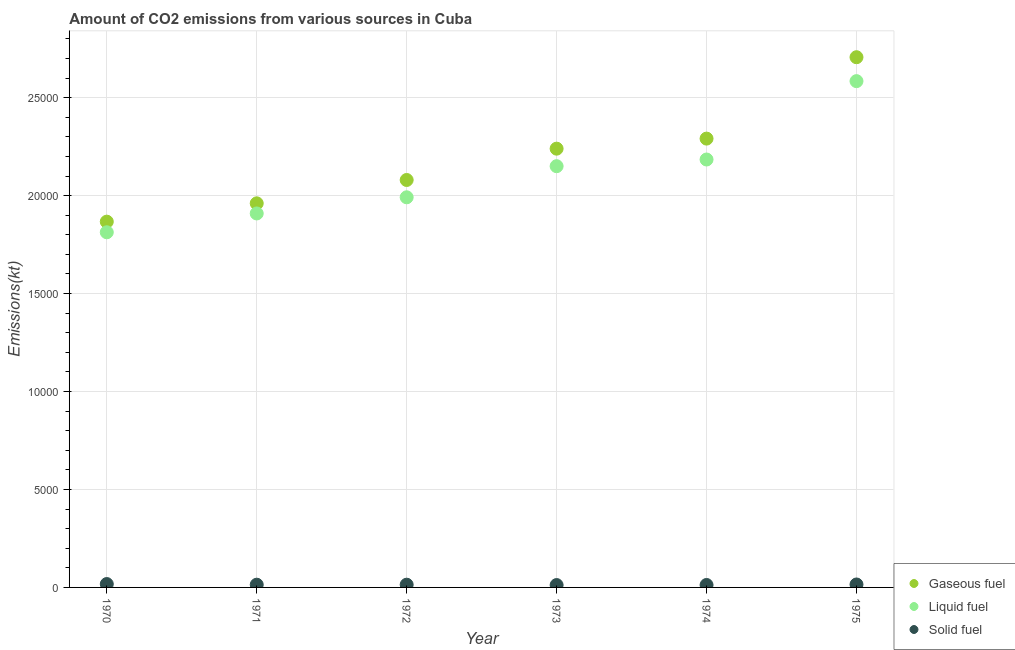How many different coloured dotlines are there?
Keep it short and to the point. 3. Is the number of dotlines equal to the number of legend labels?
Your answer should be very brief. Yes. What is the amount of co2 emissions from gaseous fuel in 1975?
Provide a succinct answer. 2.71e+04. Across all years, what is the maximum amount of co2 emissions from liquid fuel?
Ensure brevity in your answer.  2.58e+04. Across all years, what is the minimum amount of co2 emissions from gaseous fuel?
Ensure brevity in your answer.  1.87e+04. In which year was the amount of co2 emissions from solid fuel maximum?
Ensure brevity in your answer.  1970. In which year was the amount of co2 emissions from liquid fuel minimum?
Keep it short and to the point. 1970. What is the total amount of co2 emissions from liquid fuel in the graph?
Offer a very short reply. 1.26e+05. What is the difference between the amount of co2 emissions from liquid fuel in 1973 and that in 1975?
Keep it short and to the point. -4341.73. What is the difference between the amount of co2 emissions from solid fuel in 1973 and the amount of co2 emissions from liquid fuel in 1971?
Offer a very short reply. -1.90e+04. What is the average amount of co2 emissions from gaseous fuel per year?
Keep it short and to the point. 2.19e+04. In the year 1972, what is the difference between the amount of co2 emissions from gaseous fuel and amount of co2 emissions from liquid fuel?
Give a very brief answer. 883.75. What is the ratio of the amount of co2 emissions from liquid fuel in 1972 to that in 1974?
Provide a succinct answer. 0.91. Is the amount of co2 emissions from gaseous fuel in 1970 less than that in 1972?
Offer a very short reply. Yes. What is the difference between the highest and the second highest amount of co2 emissions from solid fuel?
Your response must be concise. 22. What is the difference between the highest and the lowest amount of co2 emissions from gaseous fuel?
Keep it short and to the point. 8393.76. Is it the case that in every year, the sum of the amount of co2 emissions from gaseous fuel and amount of co2 emissions from liquid fuel is greater than the amount of co2 emissions from solid fuel?
Offer a very short reply. Yes. Is the amount of co2 emissions from solid fuel strictly greater than the amount of co2 emissions from gaseous fuel over the years?
Your answer should be very brief. No. Does the graph contain any zero values?
Provide a succinct answer. No. Where does the legend appear in the graph?
Provide a short and direct response. Bottom right. How many legend labels are there?
Provide a succinct answer. 3. What is the title of the graph?
Provide a short and direct response. Amount of CO2 emissions from various sources in Cuba. Does "ICT services" appear as one of the legend labels in the graph?
Your answer should be very brief. No. What is the label or title of the Y-axis?
Your answer should be very brief. Emissions(kt). What is the Emissions(kt) in Gaseous fuel in 1970?
Your response must be concise. 1.87e+04. What is the Emissions(kt) in Liquid fuel in 1970?
Your response must be concise. 1.81e+04. What is the Emissions(kt) in Solid fuel in 1970?
Your response must be concise. 172.35. What is the Emissions(kt) in Gaseous fuel in 1971?
Your answer should be very brief. 1.96e+04. What is the Emissions(kt) in Liquid fuel in 1971?
Offer a terse response. 1.91e+04. What is the Emissions(kt) in Solid fuel in 1971?
Keep it short and to the point. 139.35. What is the Emissions(kt) of Gaseous fuel in 1972?
Your answer should be very brief. 2.08e+04. What is the Emissions(kt) of Liquid fuel in 1972?
Ensure brevity in your answer.  1.99e+04. What is the Emissions(kt) of Solid fuel in 1972?
Provide a short and direct response. 139.35. What is the Emissions(kt) in Gaseous fuel in 1973?
Offer a very short reply. 2.24e+04. What is the Emissions(kt) of Liquid fuel in 1973?
Ensure brevity in your answer.  2.15e+04. What is the Emissions(kt) in Solid fuel in 1973?
Give a very brief answer. 121.01. What is the Emissions(kt) in Gaseous fuel in 1974?
Your answer should be very brief. 2.29e+04. What is the Emissions(kt) of Liquid fuel in 1974?
Your answer should be compact. 2.18e+04. What is the Emissions(kt) of Solid fuel in 1974?
Ensure brevity in your answer.  124.68. What is the Emissions(kt) of Gaseous fuel in 1975?
Offer a terse response. 2.71e+04. What is the Emissions(kt) in Liquid fuel in 1975?
Ensure brevity in your answer.  2.58e+04. What is the Emissions(kt) of Solid fuel in 1975?
Provide a succinct answer. 150.35. Across all years, what is the maximum Emissions(kt) of Gaseous fuel?
Give a very brief answer. 2.71e+04. Across all years, what is the maximum Emissions(kt) in Liquid fuel?
Ensure brevity in your answer.  2.58e+04. Across all years, what is the maximum Emissions(kt) in Solid fuel?
Keep it short and to the point. 172.35. Across all years, what is the minimum Emissions(kt) in Gaseous fuel?
Provide a short and direct response. 1.87e+04. Across all years, what is the minimum Emissions(kt) of Liquid fuel?
Make the answer very short. 1.81e+04. Across all years, what is the minimum Emissions(kt) of Solid fuel?
Your response must be concise. 121.01. What is the total Emissions(kt) of Gaseous fuel in the graph?
Your answer should be compact. 1.31e+05. What is the total Emissions(kt) in Liquid fuel in the graph?
Provide a succinct answer. 1.26e+05. What is the total Emissions(kt) in Solid fuel in the graph?
Make the answer very short. 847.08. What is the difference between the Emissions(kt) in Gaseous fuel in 1970 and that in 1971?
Your response must be concise. -935.09. What is the difference between the Emissions(kt) of Liquid fuel in 1970 and that in 1971?
Make the answer very short. -960.75. What is the difference between the Emissions(kt) of Solid fuel in 1970 and that in 1971?
Provide a succinct answer. 33. What is the difference between the Emissions(kt) in Gaseous fuel in 1970 and that in 1972?
Make the answer very short. -2126.86. What is the difference between the Emissions(kt) in Liquid fuel in 1970 and that in 1972?
Offer a terse response. -1785.83. What is the difference between the Emissions(kt) in Solid fuel in 1970 and that in 1972?
Ensure brevity in your answer.  33. What is the difference between the Emissions(kt) in Gaseous fuel in 1970 and that in 1973?
Ensure brevity in your answer.  -3725.67. What is the difference between the Emissions(kt) in Liquid fuel in 1970 and that in 1973?
Keep it short and to the point. -3373.64. What is the difference between the Emissions(kt) of Solid fuel in 1970 and that in 1973?
Give a very brief answer. 51.34. What is the difference between the Emissions(kt) of Gaseous fuel in 1970 and that in 1974?
Ensure brevity in your answer.  -4239.05. What is the difference between the Emissions(kt) in Liquid fuel in 1970 and that in 1974?
Make the answer very short. -3714.67. What is the difference between the Emissions(kt) of Solid fuel in 1970 and that in 1974?
Your answer should be very brief. 47.67. What is the difference between the Emissions(kt) in Gaseous fuel in 1970 and that in 1975?
Your answer should be very brief. -8393.76. What is the difference between the Emissions(kt) of Liquid fuel in 1970 and that in 1975?
Your answer should be very brief. -7715.37. What is the difference between the Emissions(kt) in Solid fuel in 1970 and that in 1975?
Provide a succinct answer. 22. What is the difference between the Emissions(kt) of Gaseous fuel in 1971 and that in 1972?
Your response must be concise. -1191.78. What is the difference between the Emissions(kt) in Liquid fuel in 1971 and that in 1972?
Provide a succinct answer. -825.08. What is the difference between the Emissions(kt) of Gaseous fuel in 1971 and that in 1973?
Provide a short and direct response. -2790.59. What is the difference between the Emissions(kt) in Liquid fuel in 1971 and that in 1973?
Provide a short and direct response. -2412.89. What is the difference between the Emissions(kt) in Solid fuel in 1971 and that in 1973?
Offer a terse response. 18.34. What is the difference between the Emissions(kt) in Gaseous fuel in 1971 and that in 1974?
Your response must be concise. -3303.97. What is the difference between the Emissions(kt) in Liquid fuel in 1971 and that in 1974?
Offer a terse response. -2753.92. What is the difference between the Emissions(kt) in Solid fuel in 1971 and that in 1974?
Keep it short and to the point. 14.67. What is the difference between the Emissions(kt) of Gaseous fuel in 1971 and that in 1975?
Your answer should be compact. -7458.68. What is the difference between the Emissions(kt) of Liquid fuel in 1971 and that in 1975?
Offer a terse response. -6754.61. What is the difference between the Emissions(kt) in Solid fuel in 1971 and that in 1975?
Provide a short and direct response. -11. What is the difference between the Emissions(kt) in Gaseous fuel in 1972 and that in 1973?
Give a very brief answer. -1598.81. What is the difference between the Emissions(kt) in Liquid fuel in 1972 and that in 1973?
Provide a short and direct response. -1587.81. What is the difference between the Emissions(kt) of Solid fuel in 1972 and that in 1973?
Offer a terse response. 18.34. What is the difference between the Emissions(kt) in Gaseous fuel in 1972 and that in 1974?
Keep it short and to the point. -2112.19. What is the difference between the Emissions(kt) in Liquid fuel in 1972 and that in 1974?
Offer a very short reply. -1928.84. What is the difference between the Emissions(kt) in Solid fuel in 1972 and that in 1974?
Provide a succinct answer. 14.67. What is the difference between the Emissions(kt) in Gaseous fuel in 1972 and that in 1975?
Keep it short and to the point. -6266.9. What is the difference between the Emissions(kt) of Liquid fuel in 1972 and that in 1975?
Provide a succinct answer. -5929.54. What is the difference between the Emissions(kt) of Solid fuel in 1972 and that in 1975?
Keep it short and to the point. -11. What is the difference between the Emissions(kt) in Gaseous fuel in 1973 and that in 1974?
Your answer should be compact. -513.38. What is the difference between the Emissions(kt) of Liquid fuel in 1973 and that in 1974?
Offer a terse response. -341.03. What is the difference between the Emissions(kt) of Solid fuel in 1973 and that in 1974?
Your response must be concise. -3.67. What is the difference between the Emissions(kt) in Gaseous fuel in 1973 and that in 1975?
Offer a terse response. -4668.09. What is the difference between the Emissions(kt) of Liquid fuel in 1973 and that in 1975?
Provide a short and direct response. -4341.73. What is the difference between the Emissions(kt) in Solid fuel in 1973 and that in 1975?
Keep it short and to the point. -29.34. What is the difference between the Emissions(kt) of Gaseous fuel in 1974 and that in 1975?
Give a very brief answer. -4154.71. What is the difference between the Emissions(kt) in Liquid fuel in 1974 and that in 1975?
Your response must be concise. -4000.7. What is the difference between the Emissions(kt) in Solid fuel in 1974 and that in 1975?
Make the answer very short. -25.67. What is the difference between the Emissions(kt) in Gaseous fuel in 1970 and the Emissions(kt) in Liquid fuel in 1971?
Give a very brief answer. -418.04. What is the difference between the Emissions(kt) in Gaseous fuel in 1970 and the Emissions(kt) in Solid fuel in 1971?
Offer a very short reply. 1.85e+04. What is the difference between the Emissions(kt) in Liquid fuel in 1970 and the Emissions(kt) in Solid fuel in 1971?
Your response must be concise. 1.80e+04. What is the difference between the Emissions(kt) of Gaseous fuel in 1970 and the Emissions(kt) of Liquid fuel in 1972?
Your answer should be very brief. -1243.11. What is the difference between the Emissions(kt) in Gaseous fuel in 1970 and the Emissions(kt) in Solid fuel in 1972?
Offer a terse response. 1.85e+04. What is the difference between the Emissions(kt) in Liquid fuel in 1970 and the Emissions(kt) in Solid fuel in 1972?
Provide a short and direct response. 1.80e+04. What is the difference between the Emissions(kt) in Gaseous fuel in 1970 and the Emissions(kt) in Liquid fuel in 1973?
Ensure brevity in your answer.  -2830.92. What is the difference between the Emissions(kt) in Gaseous fuel in 1970 and the Emissions(kt) in Solid fuel in 1973?
Give a very brief answer. 1.86e+04. What is the difference between the Emissions(kt) in Liquid fuel in 1970 and the Emissions(kt) in Solid fuel in 1973?
Provide a short and direct response. 1.80e+04. What is the difference between the Emissions(kt) in Gaseous fuel in 1970 and the Emissions(kt) in Liquid fuel in 1974?
Ensure brevity in your answer.  -3171.95. What is the difference between the Emissions(kt) of Gaseous fuel in 1970 and the Emissions(kt) of Solid fuel in 1974?
Your response must be concise. 1.85e+04. What is the difference between the Emissions(kt) in Liquid fuel in 1970 and the Emissions(kt) in Solid fuel in 1974?
Give a very brief answer. 1.80e+04. What is the difference between the Emissions(kt) in Gaseous fuel in 1970 and the Emissions(kt) in Liquid fuel in 1975?
Your answer should be compact. -7172.65. What is the difference between the Emissions(kt) in Gaseous fuel in 1970 and the Emissions(kt) in Solid fuel in 1975?
Give a very brief answer. 1.85e+04. What is the difference between the Emissions(kt) in Liquid fuel in 1970 and the Emissions(kt) in Solid fuel in 1975?
Your response must be concise. 1.80e+04. What is the difference between the Emissions(kt) of Gaseous fuel in 1971 and the Emissions(kt) of Liquid fuel in 1972?
Your response must be concise. -308.03. What is the difference between the Emissions(kt) of Gaseous fuel in 1971 and the Emissions(kt) of Solid fuel in 1972?
Your answer should be compact. 1.95e+04. What is the difference between the Emissions(kt) of Liquid fuel in 1971 and the Emissions(kt) of Solid fuel in 1972?
Your answer should be compact. 1.90e+04. What is the difference between the Emissions(kt) in Gaseous fuel in 1971 and the Emissions(kt) in Liquid fuel in 1973?
Offer a terse response. -1895.84. What is the difference between the Emissions(kt) in Gaseous fuel in 1971 and the Emissions(kt) in Solid fuel in 1973?
Keep it short and to the point. 1.95e+04. What is the difference between the Emissions(kt) of Liquid fuel in 1971 and the Emissions(kt) of Solid fuel in 1973?
Offer a terse response. 1.90e+04. What is the difference between the Emissions(kt) in Gaseous fuel in 1971 and the Emissions(kt) in Liquid fuel in 1974?
Your answer should be very brief. -2236.87. What is the difference between the Emissions(kt) in Gaseous fuel in 1971 and the Emissions(kt) in Solid fuel in 1974?
Offer a very short reply. 1.95e+04. What is the difference between the Emissions(kt) in Liquid fuel in 1971 and the Emissions(kt) in Solid fuel in 1974?
Offer a terse response. 1.90e+04. What is the difference between the Emissions(kt) of Gaseous fuel in 1971 and the Emissions(kt) of Liquid fuel in 1975?
Provide a succinct answer. -6237.57. What is the difference between the Emissions(kt) in Gaseous fuel in 1971 and the Emissions(kt) in Solid fuel in 1975?
Give a very brief answer. 1.95e+04. What is the difference between the Emissions(kt) in Liquid fuel in 1971 and the Emissions(kt) in Solid fuel in 1975?
Your answer should be compact. 1.89e+04. What is the difference between the Emissions(kt) in Gaseous fuel in 1972 and the Emissions(kt) in Liquid fuel in 1973?
Your answer should be very brief. -704.06. What is the difference between the Emissions(kt) of Gaseous fuel in 1972 and the Emissions(kt) of Solid fuel in 1973?
Your answer should be very brief. 2.07e+04. What is the difference between the Emissions(kt) of Liquid fuel in 1972 and the Emissions(kt) of Solid fuel in 1973?
Provide a succinct answer. 1.98e+04. What is the difference between the Emissions(kt) in Gaseous fuel in 1972 and the Emissions(kt) in Liquid fuel in 1974?
Offer a terse response. -1045.1. What is the difference between the Emissions(kt) in Gaseous fuel in 1972 and the Emissions(kt) in Solid fuel in 1974?
Ensure brevity in your answer.  2.07e+04. What is the difference between the Emissions(kt) of Liquid fuel in 1972 and the Emissions(kt) of Solid fuel in 1974?
Your answer should be compact. 1.98e+04. What is the difference between the Emissions(kt) of Gaseous fuel in 1972 and the Emissions(kt) of Liquid fuel in 1975?
Provide a succinct answer. -5045.79. What is the difference between the Emissions(kt) of Gaseous fuel in 1972 and the Emissions(kt) of Solid fuel in 1975?
Make the answer very short. 2.06e+04. What is the difference between the Emissions(kt) of Liquid fuel in 1972 and the Emissions(kt) of Solid fuel in 1975?
Give a very brief answer. 1.98e+04. What is the difference between the Emissions(kt) in Gaseous fuel in 1973 and the Emissions(kt) in Liquid fuel in 1974?
Offer a very short reply. 553.72. What is the difference between the Emissions(kt) in Gaseous fuel in 1973 and the Emissions(kt) in Solid fuel in 1974?
Ensure brevity in your answer.  2.23e+04. What is the difference between the Emissions(kt) of Liquid fuel in 1973 and the Emissions(kt) of Solid fuel in 1974?
Offer a very short reply. 2.14e+04. What is the difference between the Emissions(kt) in Gaseous fuel in 1973 and the Emissions(kt) in Liquid fuel in 1975?
Ensure brevity in your answer.  -3446.98. What is the difference between the Emissions(kt) in Gaseous fuel in 1973 and the Emissions(kt) in Solid fuel in 1975?
Offer a terse response. 2.22e+04. What is the difference between the Emissions(kt) in Liquid fuel in 1973 and the Emissions(kt) in Solid fuel in 1975?
Your answer should be very brief. 2.14e+04. What is the difference between the Emissions(kt) in Gaseous fuel in 1974 and the Emissions(kt) in Liquid fuel in 1975?
Provide a short and direct response. -2933.6. What is the difference between the Emissions(kt) of Gaseous fuel in 1974 and the Emissions(kt) of Solid fuel in 1975?
Offer a terse response. 2.28e+04. What is the difference between the Emissions(kt) in Liquid fuel in 1974 and the Emissions(kt) in Solid fuel in 1975?
Your answer should be very brief. 2.17e+04. What is the average Emissions(kt) in Gaseous fuel per year?
Your answer should be compact. 2.19e+04. What is the average Emissions(kt) in Liquid fuel per year?
Offer a terse response. 2.11e+04. What is the average Emissions(kt) in Solid fuel per year?
Make the answer very short. 141.18. In the year 1970, what is the difference between the Emissions(kt) of Gaseous fuel and Emissions(kt) of Liquid fuel?
Offer a very short reply. 542.72. In the year 1970, what is the difference between the Emissions(kt) in Gaseous fuel and Emissions(kt) in Solid fuel?
Make the answer very short. 1.85e+04. In the year 1970, what is the difference between the Emissions(kt) in Liquid fuel and Emissions(kt) in Solid fuel?
Make the answer very short. 1.80e+04. In the year 1971, what is the difference between the Emissions(kt) in Gaseous fuel and Emissions(kt) in Liquid fuel?
Provide a succinct answer. 517.05. In the year 1971, what is the difference between the Emissions(kt) of Gaseous fuel and Emissions(kt) of Solid fuel?
Your answer should be compact. 1.95e+04. In the year 1971, what is the difference between the Emissions(kt) in Liquid fuel and Emissions(kt) in Solid fuel?
Provide a short and direct response. 1.90e+04. In the year 1972, what is the difference between the Emissions(kt) of Gaseous fuel and Emissions(kt) of Liquid fuel?
Your response must be concise. 883.75. In the year 1972, what is the difference between the Emissions(kt) in Gaseous fuel and Emissions(kt) in Solid fuel?
Provide a succinct answer. 2.07e+04. In the year 1972, what is the difference between the Emissions(kt) of Liquid fuel and Emissions(kt) of Solid fuel?
Provide a succinct answer. 1.98e+04. In the year 1973, what is the difference between the Emissions(kt) in Gaseous fuel and Emissions(kt) in Liquid fuel?
Offer a terse response. 894.75. In the year 1973, what is the difference between the Emissions(kt) in Gaseous fuel and Emissions(kt) in Solid fuel?
Offer a very short reply. 2.23e+04. In the year 1973, what is the difference between the Emissions(kt) in Liquid fuel and Emissions(kt) in Solid fuel?
Ensure brevity in your answer.  2.14e+04. In the year 1974, what is the difference between the Emissions(kt) of Gaseous fuel and Emissions(kt) of Liquid fuel?
Keep it short and to the point. 1067.1. In the year 1974, what is the difference between the Emissions(kt) of Gaseous fuel and Emissions(kt) of Solid fuel?
Your response must be concise. 2.28e+04. In the year 1974, what is the difference between the Emissions(kt) of Liquid fuel and Emissions(kt) of Solid fuel?
Your answer should be compact. 2.17e+04. In the year 1975, what is the difference between the Emissions(kt) of Gaseous fuel and Emissions(kt) of Liquid fuel?
Provide a succinct answer. 1221.11. In the year 1975, what is the difference between the Emissions(kt) in Gaseous fuel and Emissions(kt) in Solid fuel?
Offer a very short reply. 2.69e+04. In the year 1975, what is the difference between the Emissions(kt) of Liquid fuel and Emissions(kt) of Solid fuel?
Keep it short and to the point. 2.57e+04. What is the ratio of the Emissions(kt) of Gaseous fuel in 1970 to that in 1971?
Provide a short and direct response. 0.95. What is the ratio of the Emissions(kt) of Liquid fuel in 1970 to that in 1971?
Offer a very short reply. 0.95. What is the ratio of the Emissions(kt) of Solid fuel in 1970 to that in 1971?
Provide a succinct answer. 1.24. What is the ratio of the Emissions(kt) of Gaseous fuel in 1970 to that in 1972?
Give a very brief answer. 0.9. What is the ratio of the Emissions(kt) of Liquid fuel in 1970 to that in 1972?
Make the answer very short. 0.91. What is the ratio of the Emissions(kt) in Solid fuel in 1970 to that in 1972?
Provide a short and direct response. 1.24. What is the ratio of the Emissions(kt) in Gaseous fuel in 1970 to that in 1973?
Your answer should be compact. 0.83. What is the ratio of the Emissions(kt) in Liquid fuel in 1970 to that in 1973?
Offer a very short reply. 0.84. What is the ratio of the Emissions(kt) of Solid fuel in 1970 to that in 1973?
Your answer should be very brief. 1.42. What is the ratio of the Emissions(kt) of Gaseous fuel in 1970 to that in 1974?
Offer a terse response. 0.81. What is the ratio of the Emissions(kt) of Liquid fuel in 1970 to that in 1974?
Your answer should be compact. 0.83. What is the ratio of the Emissions(kt) of Solid fuel in 1970 to that in 1974?
Your answer should be very brief. 1.38. What is the ratio of the Emissions(kt) in Gaseous fuel in 1970 to that in 1975?
Offer a very short reply. 0.69. What is the ratio of the Emissions(kt) of Liquid fuel in 1970 to that in 1975?
Offer a terse response. 0.7. What is the ratio of the Emissions(kt) of Solid fuel in 1970 to that in 1975?
Give a very brief answer. 1.15. What is the ratio of the Emissions(kt) of Gaseous fuel in 1971 to that in 1972?
Offer a terse response. 0.94. What is the ratio of the Emissions(kt) of Liquid fuel in 1971 to that in 1972?
Provide a short and direct response. 0.96. What is the ratio of the Emissions(kt) of Solid fuel in 1971 to that in 1972?
Provide a short and direct response. 1. What is the ratio of the Emissions(kt) in Gaseous fuel in 1971 to that in 1973?
Your answer should be compact. 0.88. What is the ratio of the Emissions(kt) in Liquid fuel in 1971 to that in 1973?
Offer a terse response. 0.89. What is the ratio of the Emissions(kt) in Solid fuel in 1971 to that in 1973?
Provide a short and direct response. 1.15. What is the ratio of the Emissions(kt) of Gaseous fuel in 1971 to that in 1974?
Ensure brevity in your answer.  0.86. What is the ratio of the Emissions(kt) in Liquid fuel in 1971 to that in 1974?
Your answer should be very brief. 0.87. What is the ratio of the Emissions(kt) in Solid fuel in 1971 to that in 1974?
Your answer should be compact. 1.12. What is the ratio of the Emissions(kt) in Gaseous fuel in 1971 to that in 1975?
Your answer should be compact. 0.72. What is the ratio of the Emissions(kt) of Liquid fuel in 1971 to that in 1975?
Offer a terse response. 0.74. What is the ratio of the Emissions(kt) in Solid fuel in 1971 to that in 1975?
Your answer should be compact. 0.93. What is the ratio of the Emissions(kt) in Liquid fuel in 1972 to that in 1973?
Give a very brief answer. 0.93. What is the ratio of the Emissions(kt) of Solid fuel in 1972 to that in 1973?
Offer a terse response. 1.15. What is the ratio of the Emissions(kt) in Gaseous fuel in 1972 to that in 1974?
Make the answer very short. 0.91. What is the ratio of the Emissions(kt) of Liquid fuel in 1972 to that in 1974?
Ensure brevity in your answer.  0.91. What is the ratio of the Emissions(kt) in Solid fuel in 1972 to that in 1974?
Your response must be concise. 1.12. What is the ratio of the Emissions(kt) of Gaseous fuel in 1972 to that in 1975?
Give a very brief answer. 0.77. What is the ratio of the Emissions(kt) in Liquid fuel in 1972 to that in 1975?
Offer a very short reply. 0.77. What is the ratio of the Emissions(kt) of Solid fuel in 1972 to that in 1975?
Offer a terse response. 0.93. What is the ratio of the Emissions(kt) of Gaseous fuel in 1973 to that in 1974?
Your answer should be very brief. 0.98. What is the ratio of the Emissions(kt) of Liquid fuel in 1973 to that in 1974?
Ensure brevity in your answer.  0.98. What is the ratio of the Emissions(kt) of Solid fuel in 1973 to that in 1974?
Ensure brevity in your answer.  0.97. What is the ratio of the Emissions(kt) of Gaseous fuel in 1973 to that in 1975?
Keep it short and to the point. 0.83. What is the ratio of the Emissions(kt) in Liquid fuel in 1973 to that in 1975?
Offer a very short reply. 0.83. What is the ratio of the Emissions(kt) in Solid fuel in 1973 to that in 1975?
Keep it short and to the point. 0.8. What is the ratio of the Emissions(kt) in Gaseous fuel in 1974 to that in 1975?
Give a very brief answer. 0.85. What is the ratio of the Emissions(kt) in Liquid fuel in 1974 to that in 1975?
Offer a terse response. 0.85. What is the ratio of the Emissions(kt) in Solid fuel in 1974 to that in 1975?
Offer a very short reply. 0.83. What is the difference between the highest and the second highest Emissions(kt) of Gaseous fuel?
Ensure brevity in your answer.  4154.71. What is the difference between the highest and the second highest Emissions(kt) in Liquid fuel?
Keep it short and to the point. 4000.7. What is the difference between the highest and the second highest Emissions(kt) in Solid fuel?
Provide a succinct answer. 22. What is the difference between the highest and the lowest Emissions(kt) in Gaseous fuel?
Offer a terse response. 8393.76. What is the difference between the highest and the lowest Emissions(kt) of Liquid fuel?
Offer a very short reply. 7715.37. What is the difference between the highest and the lowest Emissions(kt) in Solid fuel?
Ensure brevity in your answer.  51.34. 